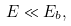Convert formula to latex. <formula><loc_0><loc_0><loc_500><loc_500>E \ll E _ { b } ,</formula> 